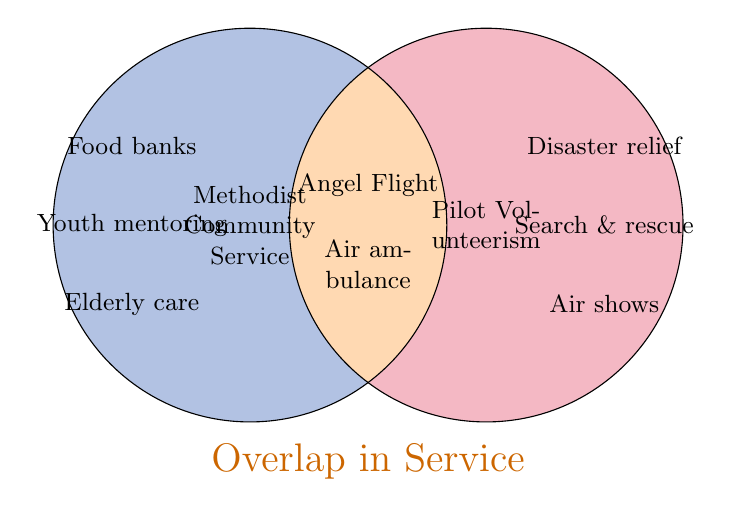What overlaps exist between Methodist community service and pilot volunteerism? The figure shows that 'Angel Flight' and 'Air ambulance services' are activities in the overlapped section of the Venn diagram, indicating they are common to both Methodist community service and pilot volunteerism.
Answer: Angel Flight and Air ambulance services Which Methodist community service activities do not overlap with pilot volunteerism? The figure lists the activities exclusive to Methodist community service: 'Food banks,' 'Youth mentoring,' and 'Elderly care.'
Answer: Food banks, Youth mentoring, Elderly care Which pilot volunteerism activities do not overlap with Methodist community service? The figure lists the activities exclusive to pilot volunteerism: 'Disaster relief,' 'Search & rescue,' and 'Air shows.'
Answer: Disaster relief, Search & rescue, Air shows What is the unique color representing pilot volunteerism in the Venn diagram? The distinct color used to represent pilot volunteerism on the right circle of the Venn diagram is red.
Answer: Red How many activities are exclusively related to Methodist community service? By counting the activities in the left circle of the Venn diagram that do not intersect with the right circle, we see three activities: 'Food banks,' 'Youth mentoring,' and 'Elderly care.'
Answer: Three How many activities are there in the overlap between Methodist community service and pilot volunteerism? In the overlapping section of the Venn diagram, we see two activities: 'Angel Flight' and 'Air ambulance services.'
Answer: Two Are there any activities listed for Methodist community service that also appear in pilot volunteerism? Yes, the activities 'Angel Flight' and 'Air ambulance services' appear in the overlap section, indicating they are common to both.
Answer: Yes How many unique activities are listed in total (both exclusive and overlapping) in the Venn diagram? Sum the unique activities: 3 from Methodist community service, 3 from pilot volunteerism, and 2 from overlap. By adding (3+2+3), the total is 8 activities.
Answer: Eight Which area of the Venn diagram is orange? The overlapping area of the Venn diagram is shaded in orange, representing shared activities between Methodist community service and pilot volunteerism.
Answer: Overlap What is one example of an activity exclusive to pilot volunteerism related to education? In the right circle of the Venn diagram, 'Search & rescue' is an exclusive pilot volunteerism activity that involves educational aspects.
Answer: Search & rescue 